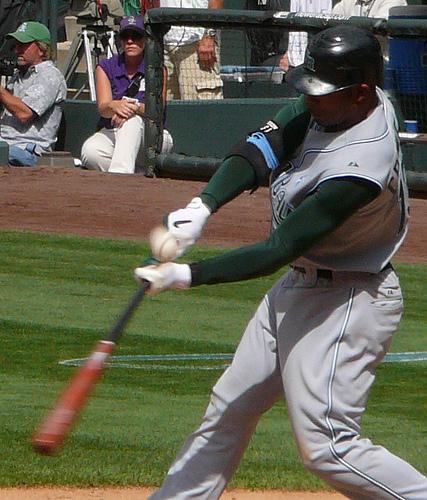Does the man hit the ball?
Answer briefly. No. What colors are the bat?
Write a very short answer. Red and black. What sport is this?
Quick response, please. Baseball. Is this man swinging properly?
Answer briefly. Yes. 